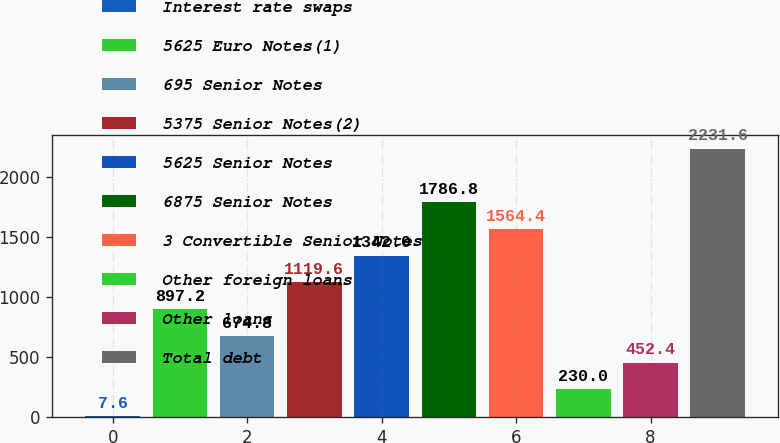Convert chart. <chart><loc_0><loc_0><loc_500><loc_500><bar_chart><fcel>Interest rate swaps<fcel>5625 Euro Notes(1)<fcel>695 Senior Notes<fcel>5375 Senior Notes(2)<fcel>5625 Senior Notes<fcel>6875 Senior Notes<fcel>3 Convertible Senior Notes<fcel>Other foreign loans<fcel>Other loans<fcel>Total debt<nl><fcel>7.6<fcel>897.2<fcel>674.8<fcel>1119.6<fcel>1342<fcel>1786.8<fcel>1564.4<fcel>230<fcel>452.4<fcel>2231.6<nl></chart> 